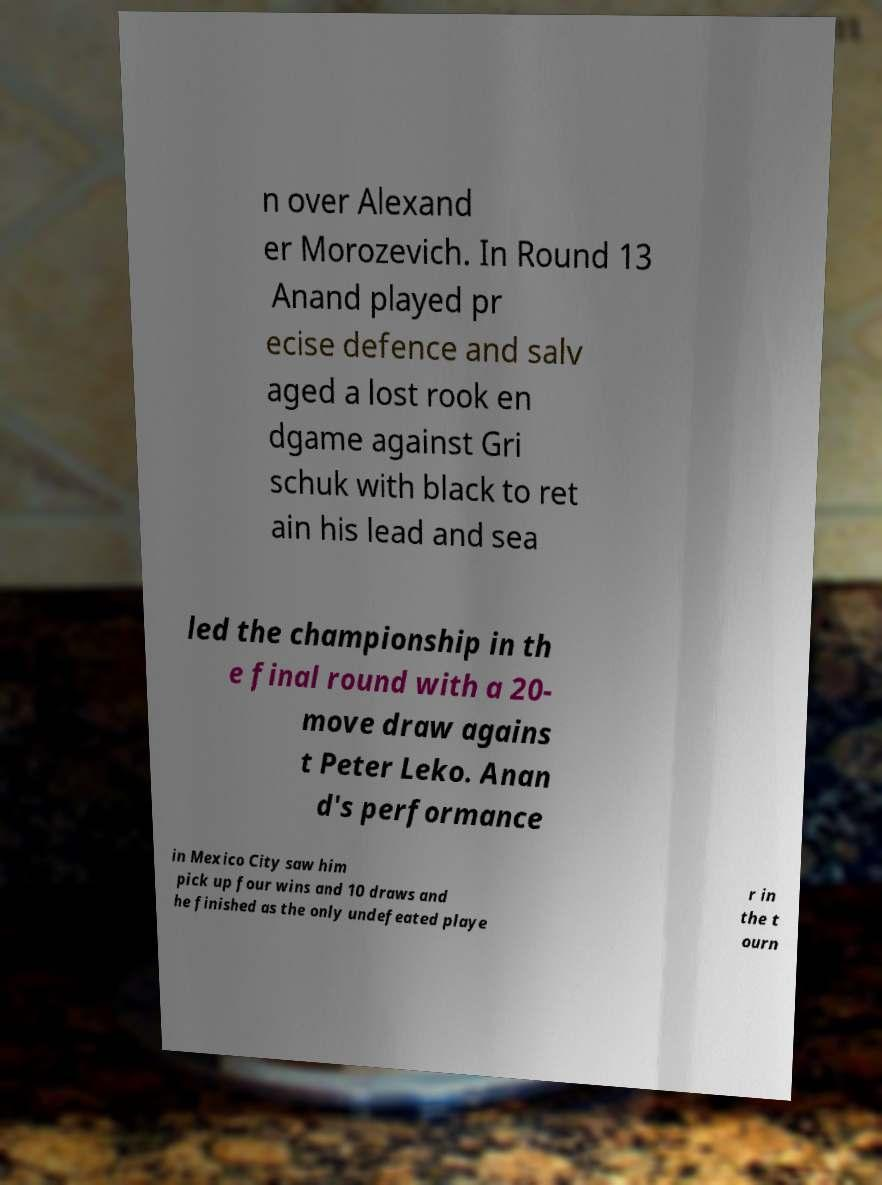What messages or text are displayed in this image? I need them in a readable, typed format. n over Alexand er Morozevich. In Round 13 Anand played pr ecise defence and salv aged a lost rook en dgame against Gri schuk with black to ret ain his lead and sea led the championship in th e final round with a 20- move draw agains t Peter Leko. Anan d's performance in Mexico City saw him pick up four wins and 10 draws and he finished as the only undefeated playe r in the t ourn 